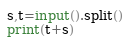<code> <loc_0><loc_0><loc_500><loc_500><_Python_>s,t=input().split()
print(t+s)</code> 